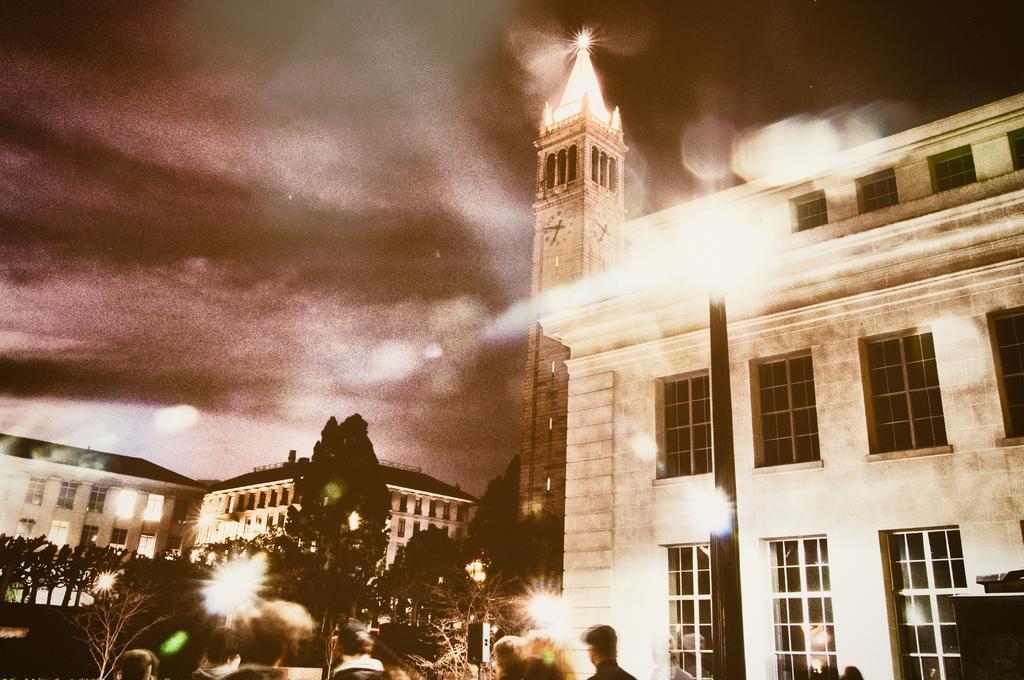How is the lighting in the image? The image is over lighted. What can be seen on the right side of the image? There is a big building on the right side of the image. What type of vegetation is on the left side of the image? There are trees on the left side of the image. How many passengers are riding the donkey in the image? There is no donkey or passengers present in the image. What type of zipper can be seen on the trees in the image? There are no zippers present on the trees in the image. 